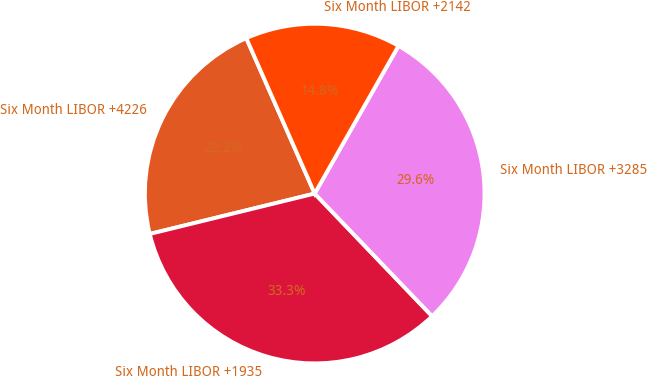Convert chart to OTSL. <chart><loc_0><loc_0><loc_500><loc_500><pie_chart><fcel>Six Month LIBOR +4226<fcel>Six Month LIBOR +1935<fcel>Six Month LIBOR +3285<fcel>Six Month LIBOR +2142<nl><fcel>22.22%<fcel>33.33%<fcel>29.63%<fcel>14.81%<nl></chart> 